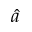Convert formula to latex. <formula><loc_0><loc_0><loc_500><loc_500>\hat { a }</formula> 